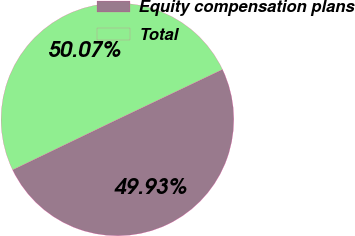Convert chart to OTSL. <chart><loc_0><loc_0><loc_500><loc_500><pie_chart><fcel>Equity compensation plans<fcel>Total<nl><fcel>49.93%<fcel>50.07%<nl></chart> 